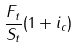Convert formula to latex. <formula><loc_0><loc_0><loc_500><loc_500>\frac { F _ { t } } { S _ { t } } ( 1 + i _ { c } )</formula> 